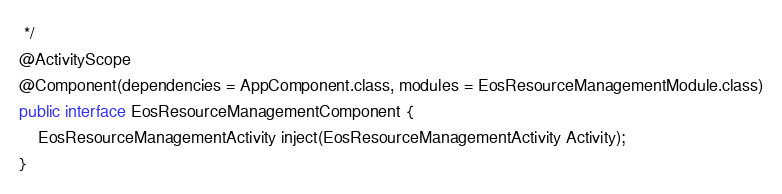<code> <loc_0><loc_0><loc_500><loc_500><_Java_> */
@ActivityScope
@Component(dependencies = AppComponent.class, modules = EosResourceManagementModule.class)
public interface EosResourceManagementComponent {
    EosResourceManagementActivity inject(EosResourceManagementActivity Activity);
}</code> 